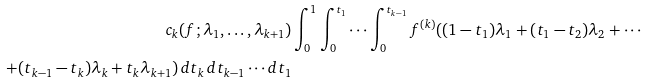<formula> <loc_0><loc_0><loc_500><loc_500>c _ { k } ( f ; \lambda _ { 1 } , \dots , \lambda _ { k + 1 } ) & \int _ { 0 } ^ { 1 } \int _ { 0 } ^ { t _ { 1 } } \cdots \int _ { 0 } ^ { t _ { k - 1 } } f ^ { ( k ) } ( ( 1 - t _ { 1 } ) \lambda _ { 1 } + ( t _ { 1 } - t _ { 2 } ) \lambda _ { 2 } + \cdots \\ + ( t _ { k - 1 } - t _ { k } ) \lambda _ { k } + t _ { k } \lambda _ { k + 1 } ) \, d t _ { k } \, d t _ { k - 1 } \cdots d t _ { 1 }</formula> 